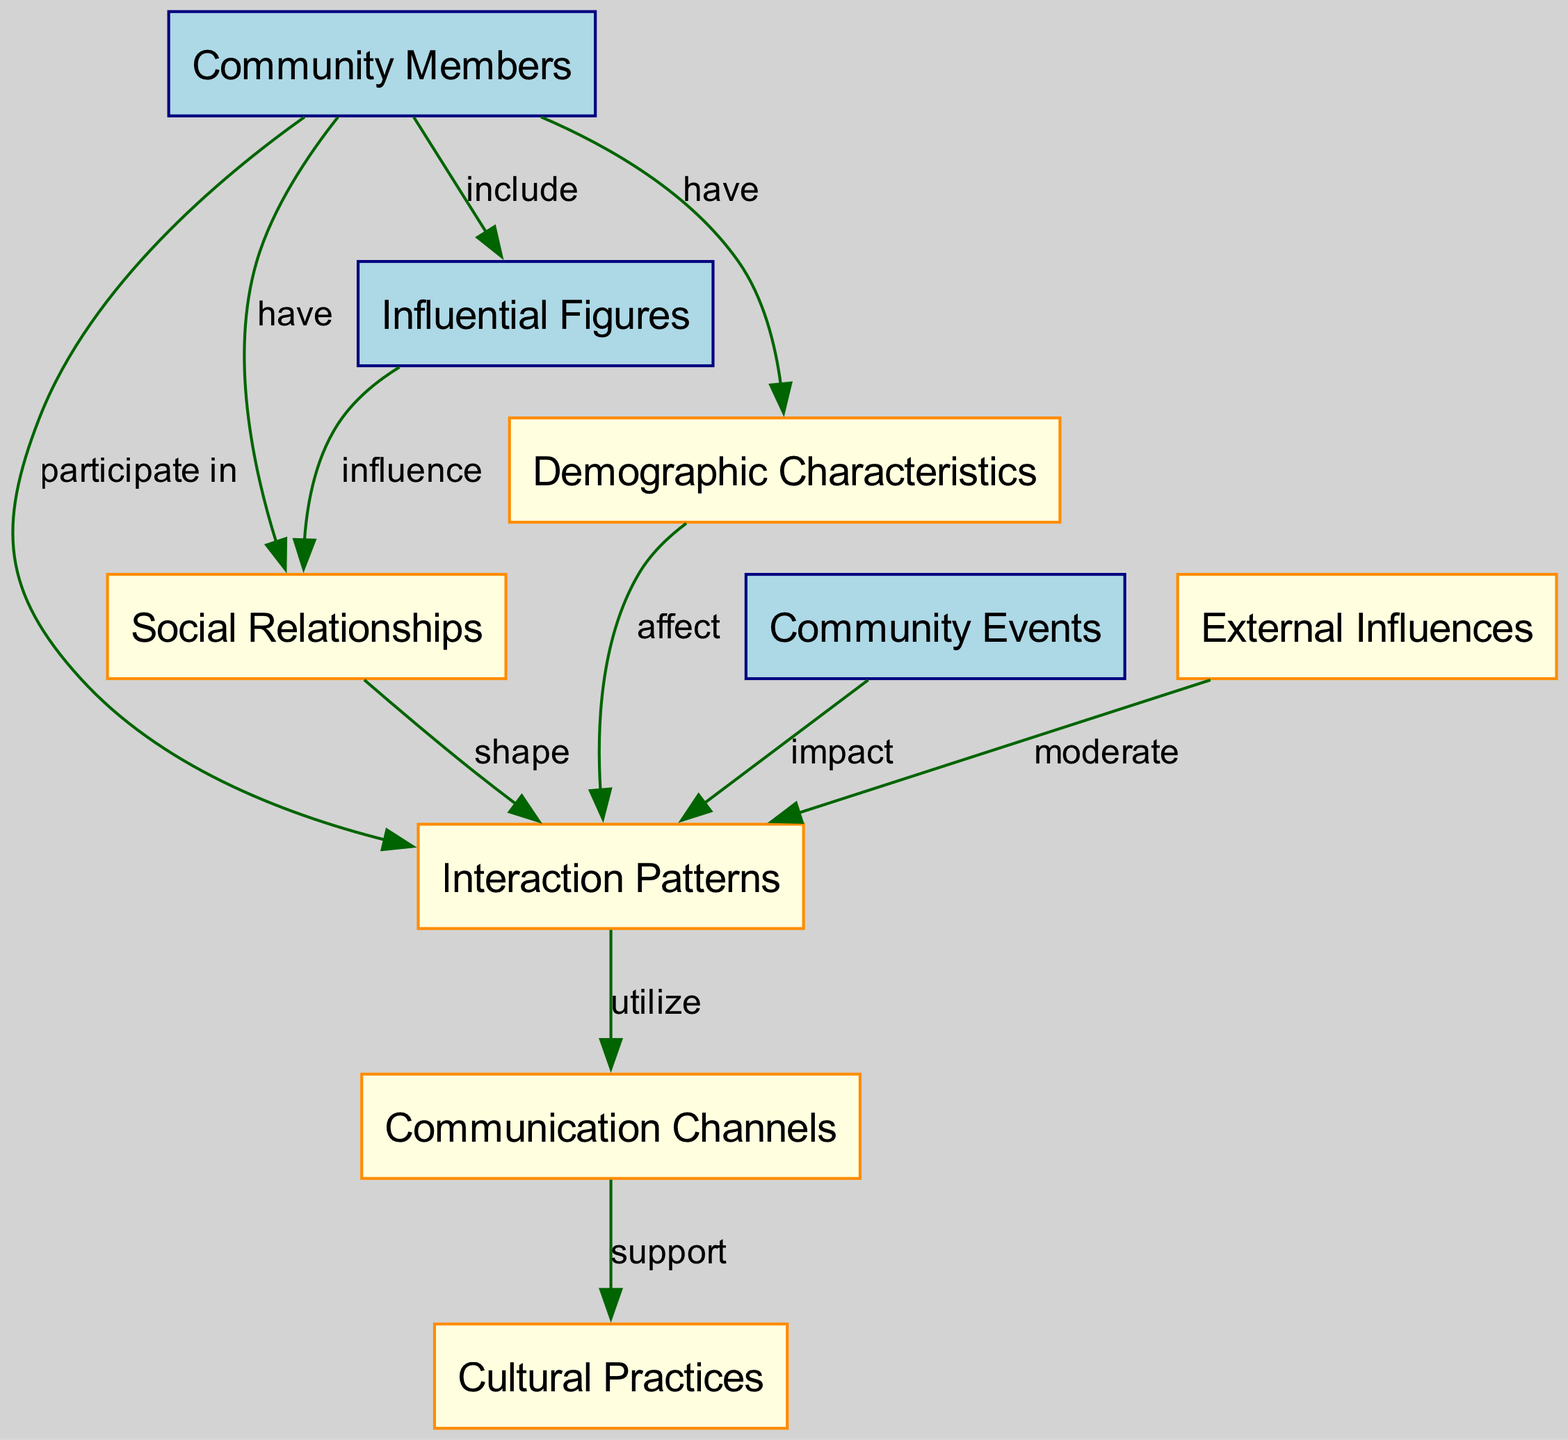What is the total number of nodes in the diagram? The total count of nodes can be found by looking at the list of entities and concepts in the diagram. By counting them, we find there are 9 nodes total.
Answer: 9 What type of relationship exists between "Community Members" and "Social Relationships"? The edge directly from "Community Members" to "Social Relationships" is labeled "have," indicating that community members possess social relationships.
Answer: have What influences "Social Relationships"? "Influential Figures" is connected to "Social Relationships" with an "influence" edge, so it plays a role in shaping these relationships, amongst other factors including "Community Events" and "External Influences."
Answer: Influential Figures How many edges connect to "Interaction Patterns"? To find this, count all the outgoing edges that originate from "Interaction Patterns." There are 4 edges directed from "Interaction Patterns" to other nodes.
Answer: 4 Which concept supports "Communication Channels"? The edge from "Communication Channels" to "Cultural Practices" is labeled "support," indicating that it provides backing to cultural practices.
Answer: Cultural Practices What is a significant factor that affects "Interaction Patterns"? The node "Demographic Characteristics" has an edge going to "Interaction Patterns" labeled "affect," suggesting that demographic aspects significantly influence interaction patterns.
Answer: Demographic Characteristics What type of nodes connect to "Community Events”? The nodes "Community Members" and "Interaction Patterns" have direct edges related to "Community Events." "Community Events" has an edge labeled "impact" going towards "Interaction Patterns," which means it connects to the concept of interaction as well as to community members.
Answer: Community Members, Interaction Patterns What is moderated by "External Influences"? "External Influences" have an edge pointing to "Interaction Patterns" with the label "moderate," indicating that these external factors regulate interaction patterns within the community.
Answer: Interaction Patterns How does "Cultural Practices" relate to "Communication Channels"? The relationship represented by the edge from "Communication Channels" to "Cultural Practices" is labeled "support," showing that cultural practices are backed by the existing communication channels.
Answer: support 